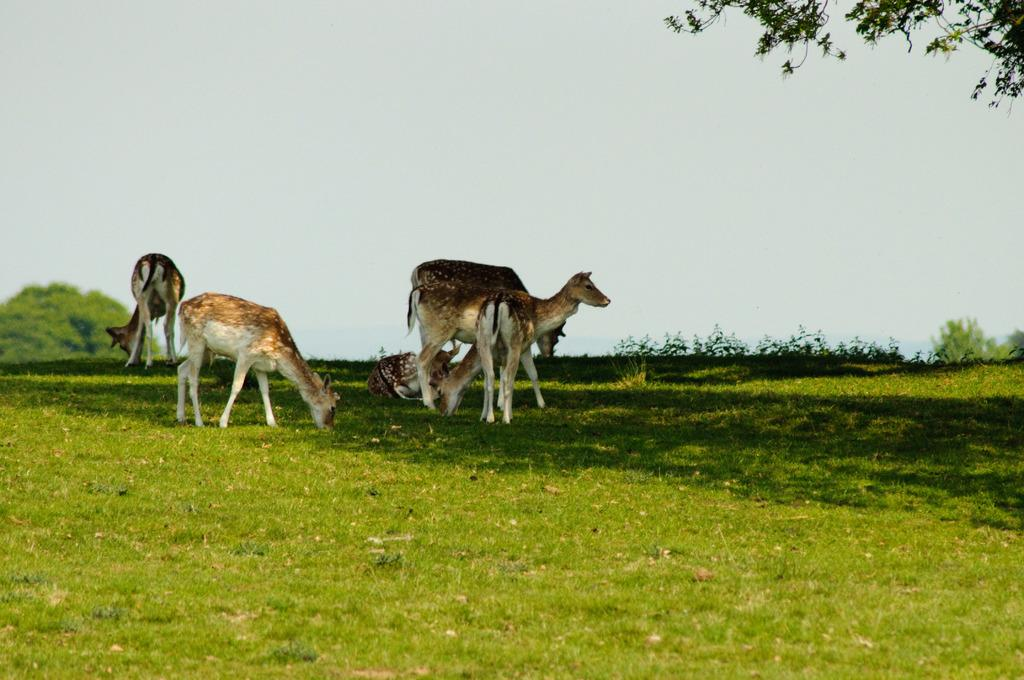What animals can be seen in the image? There are deers in the image. What type of surface are the deers standing on? The deers are on a grass surface. What can be seen in the background of the image? There is a tree in the background of the image. What is visible on the right side of the image? There are branches of a tree on the right side of the image. What songs are the deers singing in the image? The deers are not singing songs in the image; they are simply standing on a grass surface. 